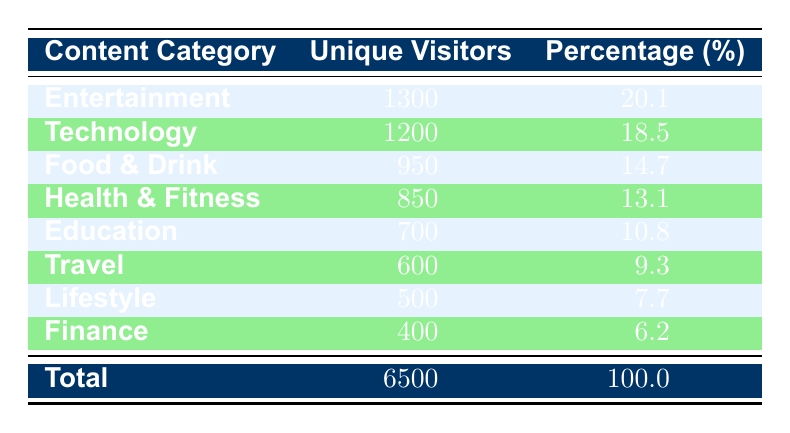What is the total unique visitors across all content categories? The total unique visitors is listed in the last row of the table, which states that the total is 6500.
Answer: 6500 Which content category has the highest number of unique visitors? Looking at the unique visitors column, Entertainment has the highest count of 1300 unique visitors.
Answer: Entertainment What percentage of unique visitors does Finance category represent? The percentage for Finance is given directly in the table, which is 6.2%.
Answer: 6.2% How many more unique visitors does Technology have compared to Travel? The unique visitors for Technology is 1200 and for Travel it is 600. The difference is calculated as 1200 - 600 = 600.
Answer: 600 Is the number of unique visitors in the Education category greater than the number in the Lifestyle category? The unique visitors for Education is 700 and for Lifestyle is 500. Since 700 is greater than 500, the statement is true.
Answer: Yes What is the average number of unique visitors across the listed content categories? To find the average, sum all unique visitors (6500) and divide by the number of categories (8), resulting in 6500 / 8 = 812.5.
Answer: 812.5 Which two categories together have the least number of unique visitors? Looking at the unique visitor counts, Finance (400) and Lifestyle (500) represent the least counts. Their sum (400 + 500 = 900) confirms this.
Answer: Finance and Lifestyle Does the Health & Fitness category have the same number of unique visitors as the combined total of Travel and Finance? Health & Fitness has 850 visitors, while the sum of Travel (600) and Finance (400) is 1000. Since 850 is not equal to 1000, the statement is false.
Answer: No How many content categories have more than 800 unique visitors? Observing the table, the categories with more than 800 unique visitors are: Technology (1200), Health & Fitness (850), Food & Drink (950), Entertainment (1300), and Education (700) -- totaling five categories.
Answer: 5 